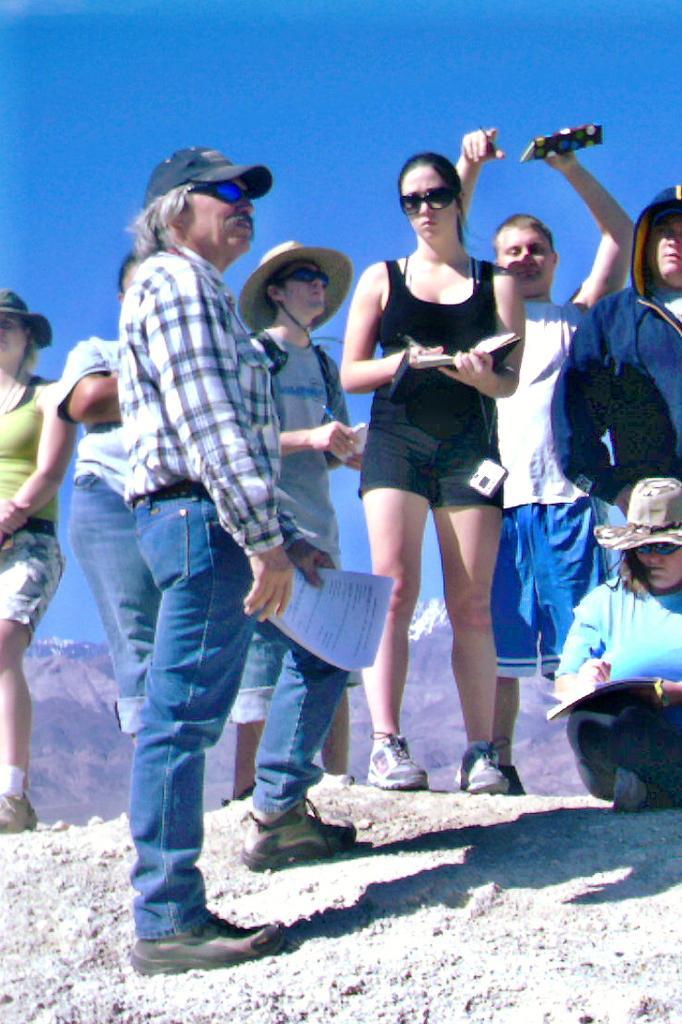In one or two sentences, can you explain what this image depicts? In this picture, we see the men and the women are standing and most of them are holding the books and the pens in their hands. The woman in the middle of the picture is holding a book and a pen in her hands. On the right side, we see a woman in the blue T-shirt who is wearing a hat is writing something in the book. There are hills in the background. At the top, we see the sky, which is blue in color. 